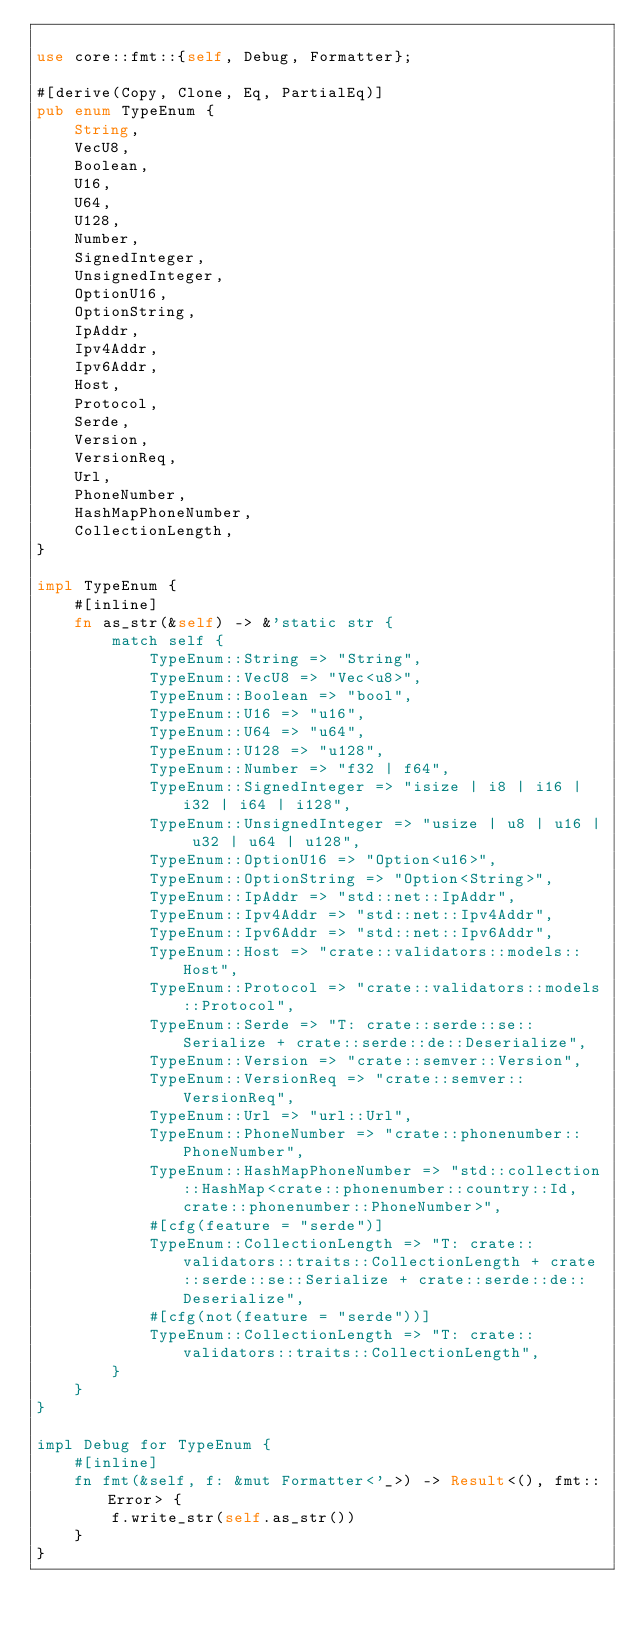Convert code to text. <code><loc_0><loc_0><loc_500><loc_500><_Rust_>
use core::fmt::{self, Debug, Formatter};

#[derive(Copy, Clone, Eq, PartialEq)]
pub enum TypeEnum {
    String,
    VecU8,
    Boolean,
    U16,
    U64,
    U128,
    Number,
    SignedInteger,
    UnsignedInteger,
    OptionU16,
    OptionString,
    IpAddr,
    Ipv4Addr,
    Ipv6Addr,
    Host,
    Protocol,
    Serde,
    Version,
    VersionReq,
    Url,
    PhoneNumber,
    HashMapPhoneNumber,
    CollectionLength,
}

impl TypeEnum {
    #[inline]
    fn as_str(&self) -> &'static str {
        match self {
            TypeEnum::String => "String",
            TypeEnum::VecU8 => "Vec<u8>",
            TypeEnum::Boolean => "bool",
            TypeEnum::U16 => "u16",
            TypeEnum::U64 => "u64",
            TypeEnum::U128 => "u128",
            TypeEnum::Number => "f32 | f64",
            TypeEnum::SignedInteger => "isize | i8 | i16 | i32 | i64 | i128",
            TypeEnum::UnsignedInteger => "usize | u8 | u16 | u32 | u64 | u128",
            TypeEnum::OptionU16 => "Option<u16>",
            TypeEnum::OptionString => "Option<String>",
            TypeEnum::IpAddr => "std::net::IpAddr",
            TypeEnum::Ipv4Addr => "std::net::Ipv4Addr",
            TypeEnum::Ipv6Addr => "std::net::Ipv6Addr",
            TypeEnum::Host => "crate::validators::models::Host",
            TypeEnum::Protocol => "crate::validators::models::Protocol",
            TypeEnum::Serde => "T: crate::serde::se::Serialize + crate::serde::de::Deserialize",
            TypeEnum::Version => "crate::semver::Version",
            TypeEnum::VersionReq => "crate::semver::VersionReq",
            TypeEnum::Url => "url::Url",
            TypeEnum::PhoneNumber => "crate::phonenumber::PhoneNumber",
            TypeEnum::HashMapPhoneNumber => "std::collection::HashMap<crate::phonenumber::country::Id, crate::phonenumber::PhoneNumber>",
            #[cfg(feature = "serde")]
            TypeEnum::CollectionLength => "T: crate::validators::traits::CollectionLength + crate::serde::se::Serialize + crate::serde::de::Deserialize",
            #[cfg(not(feature = "serde"))]
            TypeEnum::CollectionLength => "T: crate::validators::traits::CollectionLength",
        }
    }
}

impl Debug for TypeEnum {
    #[inline]
    fn fmt(&self, f: &mut Formatter<'_>) -> Result<(), fmt::Error> {
        f.write_str(self.as_str())
    }
}
</code> 